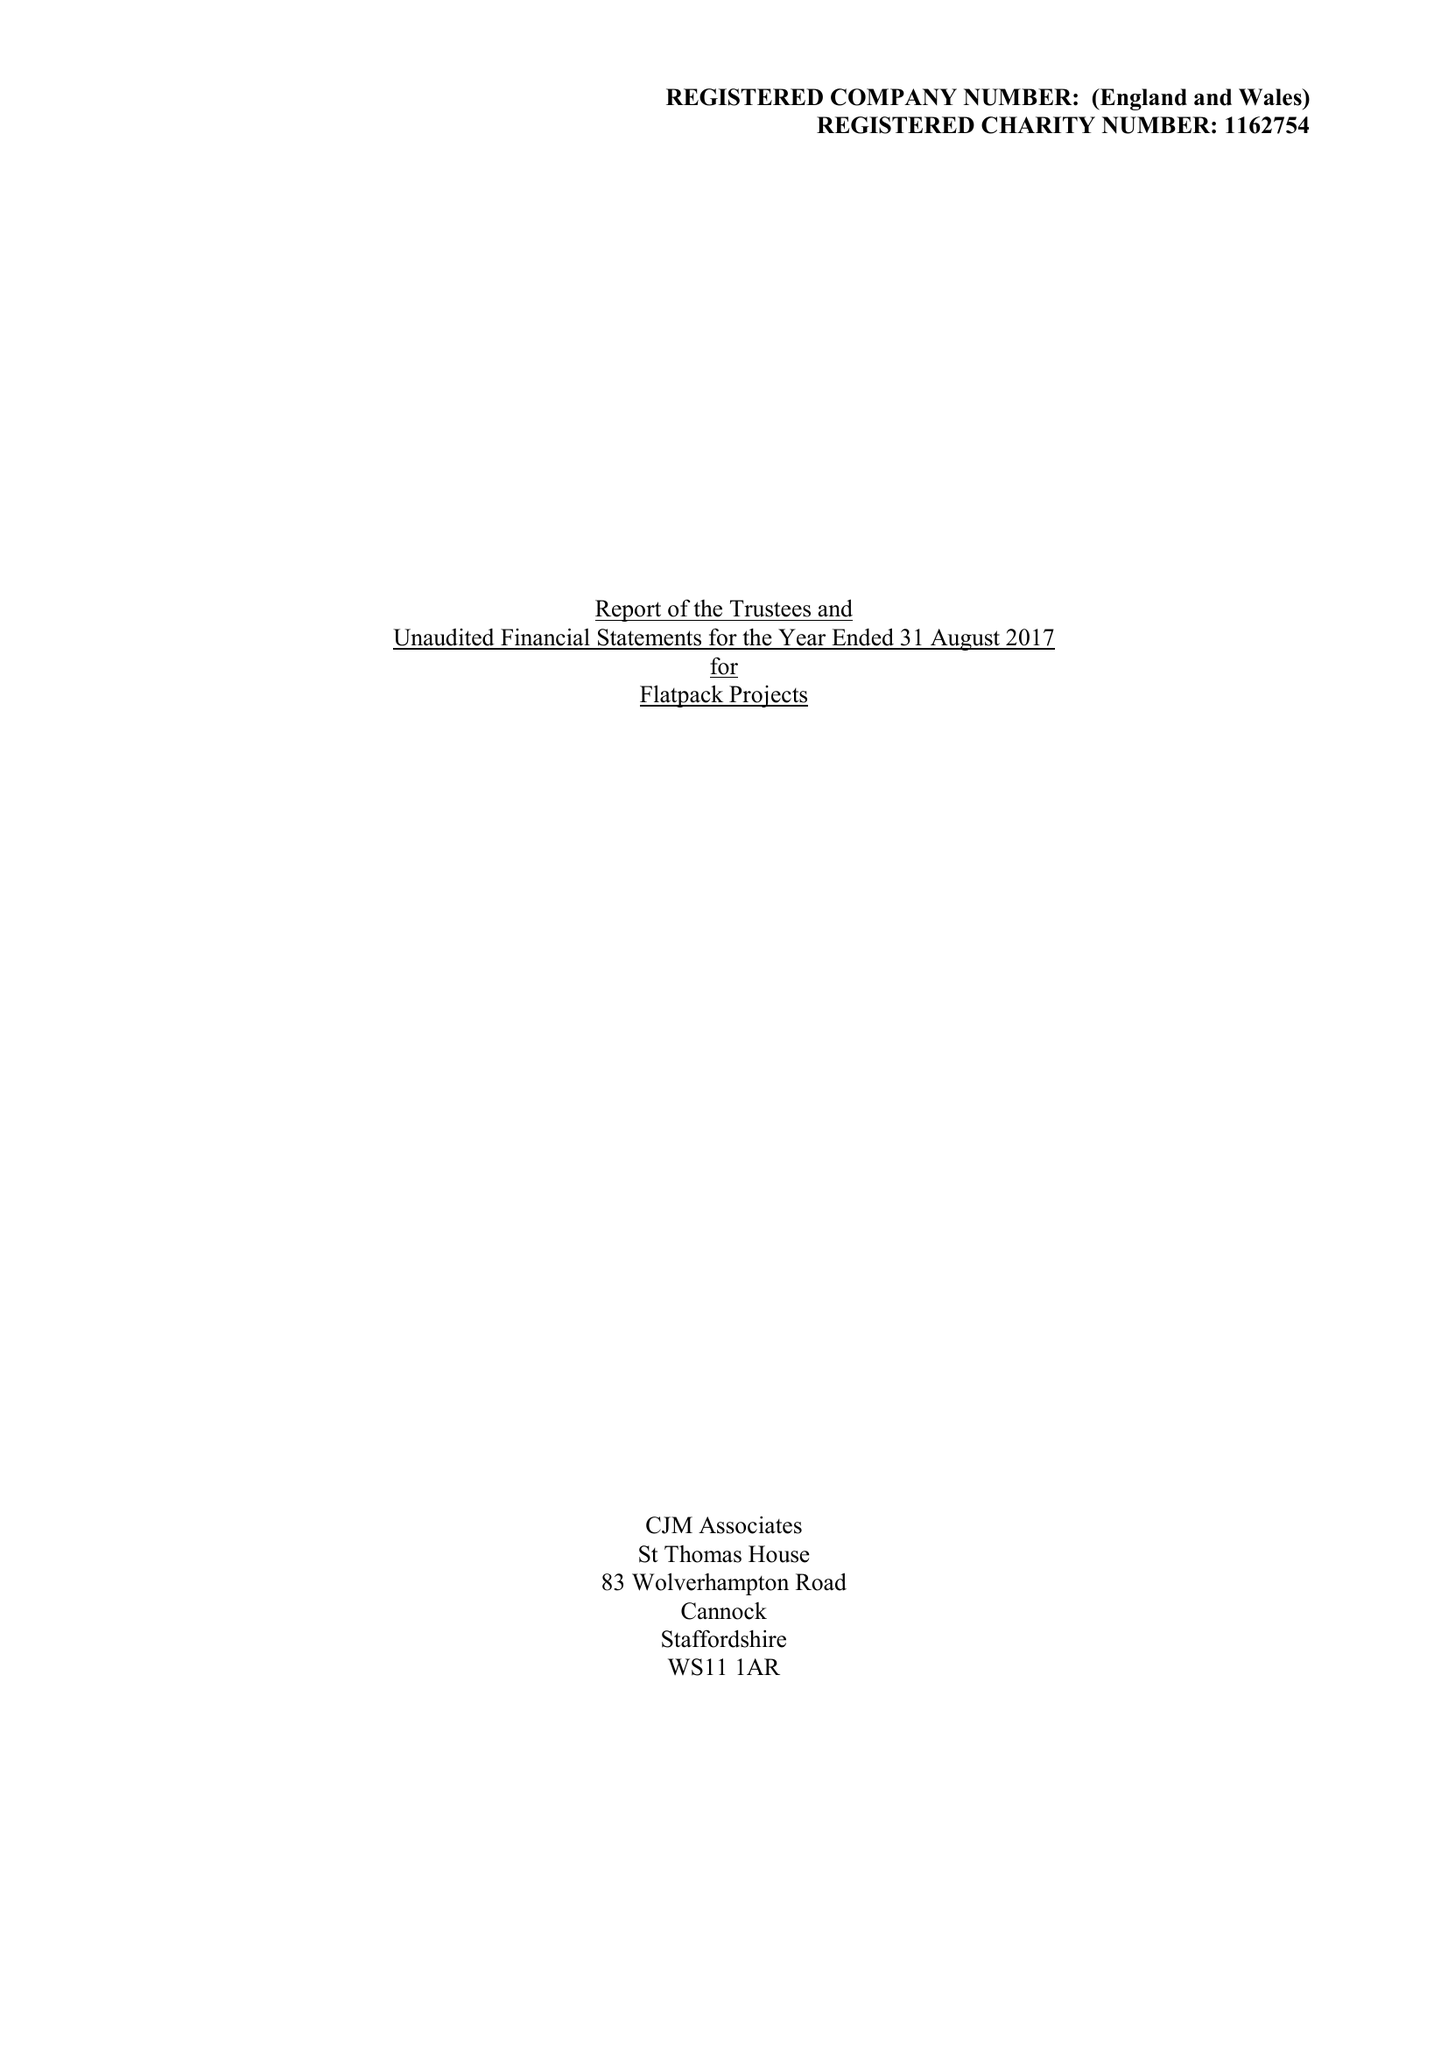What is the value for the income_annually_in_british_pounds?
Answer the question using a single word or phrase. 393412.00 